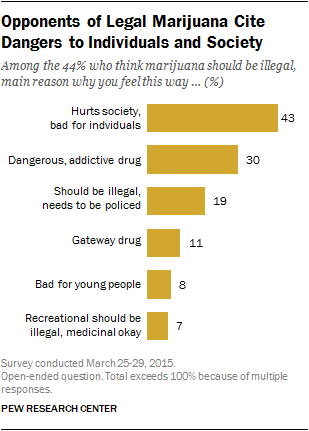Outline some significant characteristics in this image. The maximum value of the yellow bar is 43. The maximum and minimum values of the yellow bar in the graph are 36 and 2, respectively. 